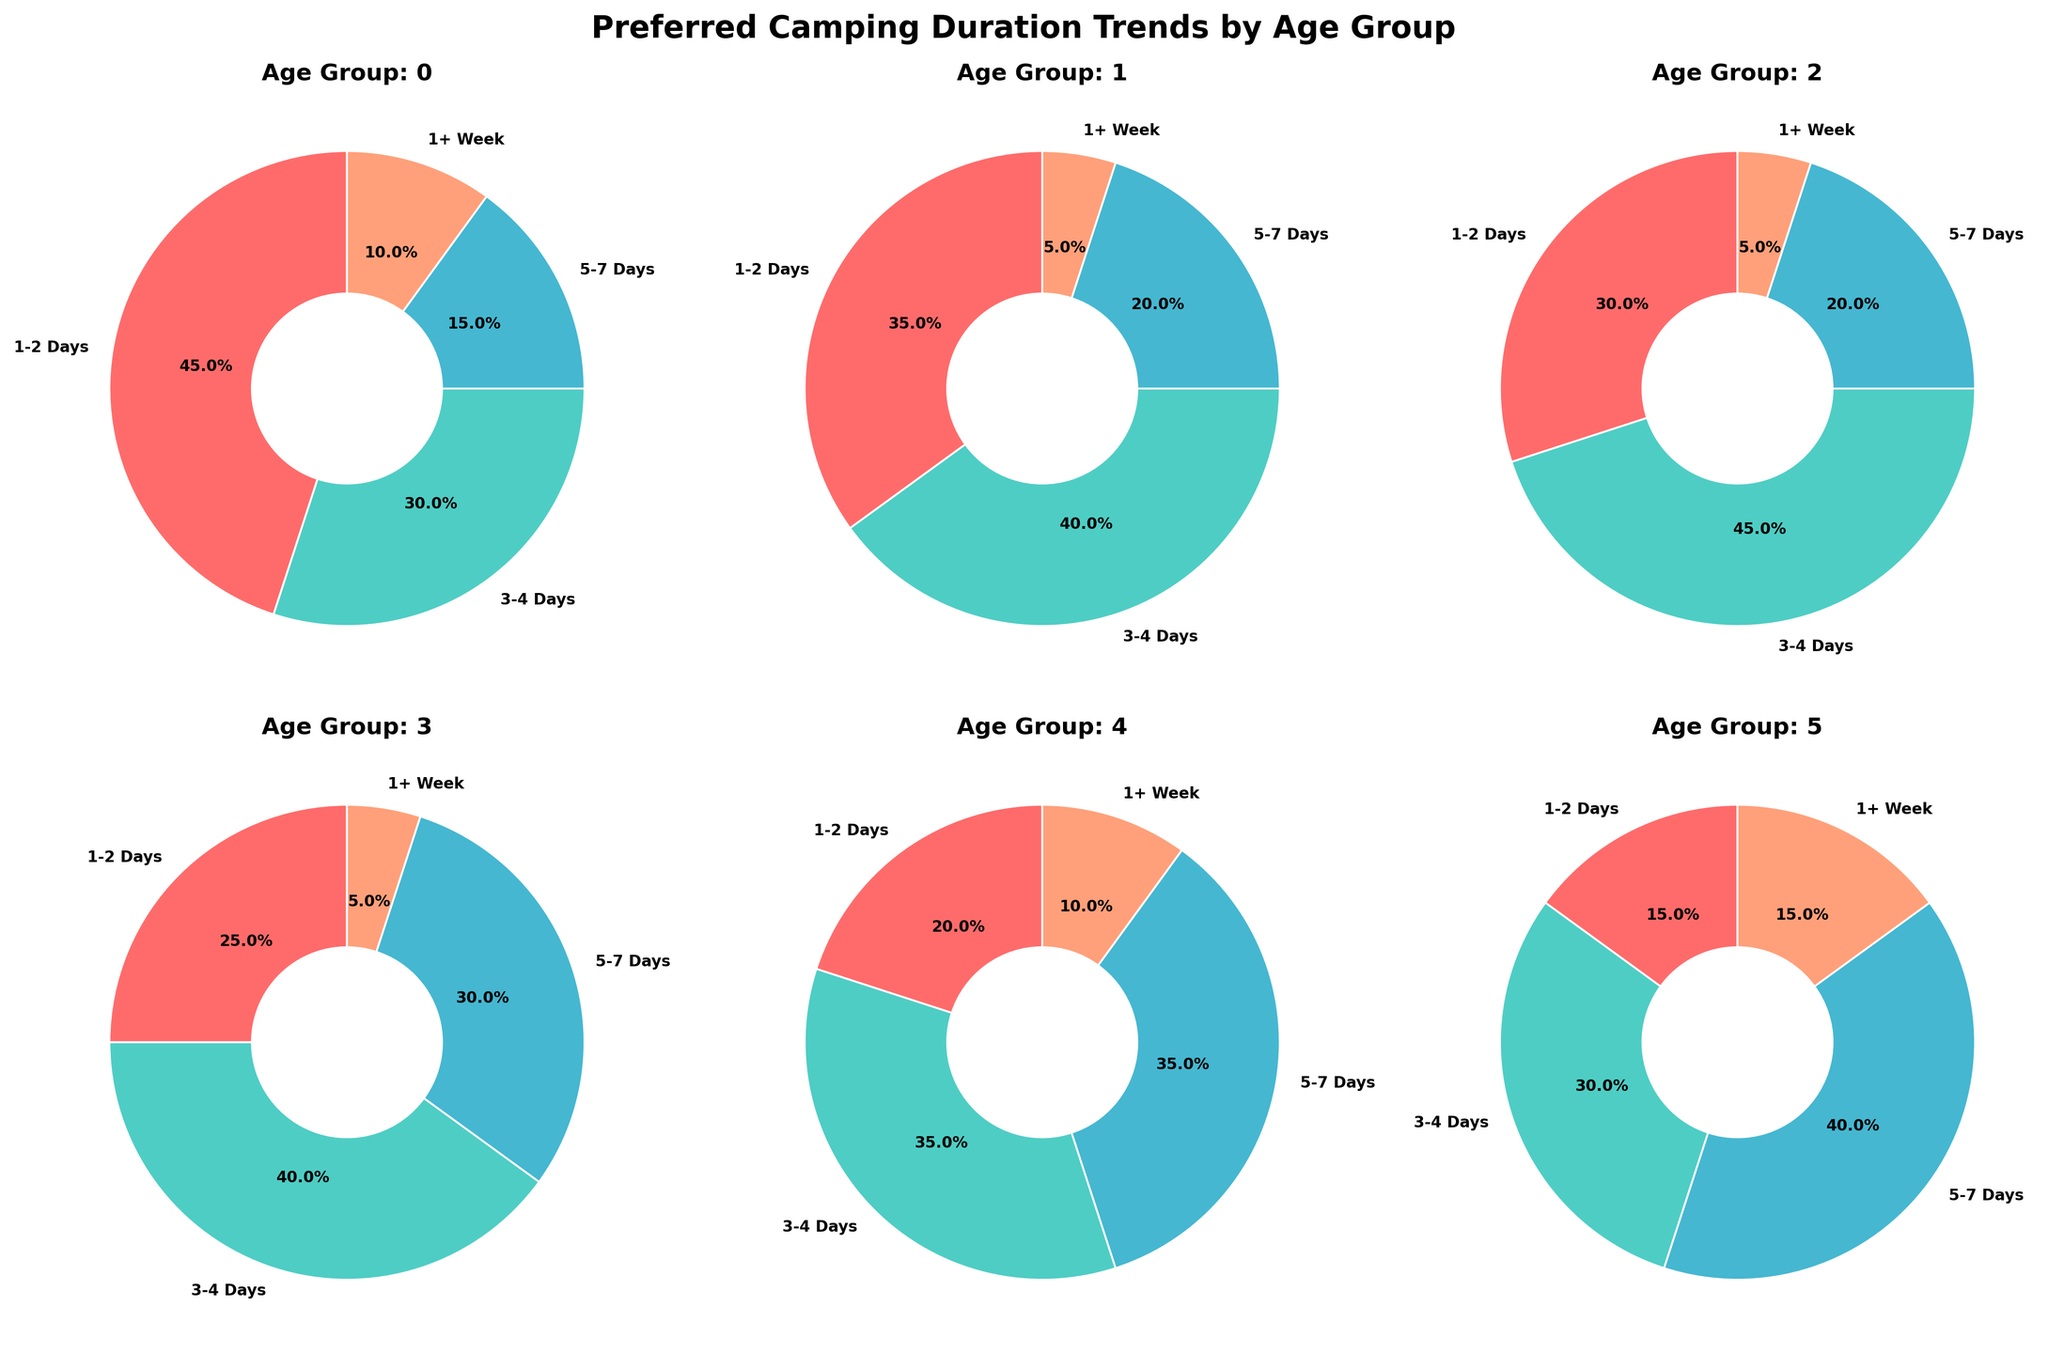Which age group prefers camping for 5-7 days the least? By examining the pie charts, the 18-25 age group has the smallest slice for the 5-7 days category
Answer: 18-25 Which age group has the highest percentage for 1+ week duration? The 65+ age group has the largest slice for the 1+ week category
Answer: 65+ What is the combined percentage preference for 1-2 days and 3-4 days for the 46-55 age group? The percentages for 1-2 days and 3-4 days in the 46-55 pie chart are 25% and 40% respectively. Summing them gives 25% + 40% = 65%
Answer: 65% Does any age group have an equal percentage for 5-7 days and 1+ week? By checking all the pie charts, no age group has equal percentages for 5-7 days and 1+ week
Answer: No What is the ratio of preference for 3-4 days to 5-7 days in the 36-45 age group? The percentages for 3-4 days and 5-7 days in the 36-45 age group are 45% and 20% respectively. The ratio is 45:20, which simplifies to 9:4
Answer: 9:4 How does the preference for 1+ week differ between the 18-25 and 26-35 age groups? The 1+ week preference for 18-25 is 10%, and for 26-35 it is 5%. The difference is 10% - 5% = 5%
Answer: 5% Which duration shows a declining trend as the age group increases? By comparing the charts, the preference for 1-2 days decreases consistently as the age groups increase
Answer: 1-2 days What percentage of 56-65 age group's preference is for durations longer than 1 week? The 56-65 age group's preference for durations longer than 1 week is 10%
Answer: 10% Which two age groups show the highest preference for 3-4 days? Both the 26-35 and 36-45 age groups have the highest slice for 3-4 days at 40% and 45% respectively
Answer: 26-35 and 36-45 In which age group is the preference for 1+ week and 1-2 days equal? The 18-25 age group has equal preference for 1+ week and 1-2 days, both are 10%
Answer: 18-25 